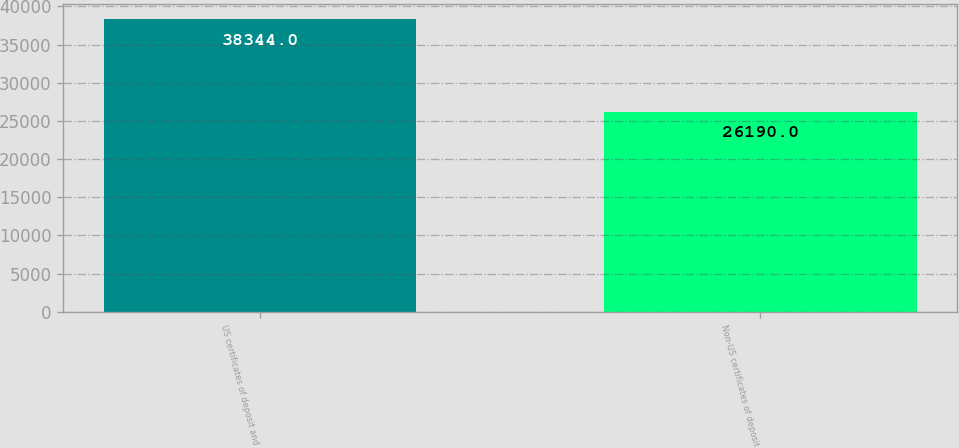Convert chart to OTSL. <chart><loc_0><loc_0><loc_500><loc_500><bar_chart><fcel>US certificates of deposit and<fcel>Non-US certificates of deposit<nl><fcel>38344<fcel>26190<nl></chart> 